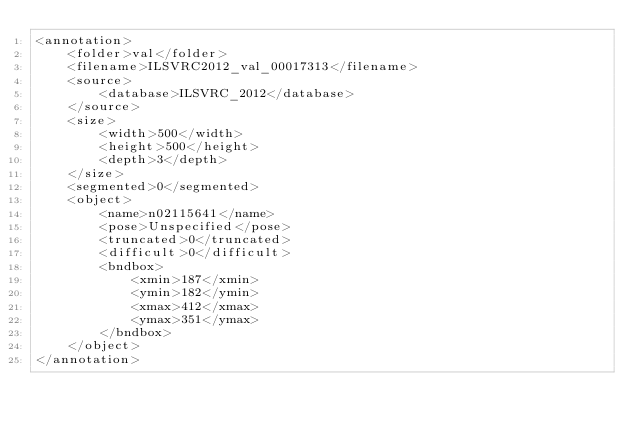Convert code to text. <code><loc_0><loc_0><loc_500><loc_500><_XML_><annotation>
	<folder>val</folder>
	<filename>ILSVRC2012_val_00017313</filename>
	<source>
		<database>ILSVRC_2012</database>
	</source>
	<size>
		<width>500</width>
		<height>500</height>
		<depth>3</depth>
	</size>
	<segmented>0</segmented>
	<object>
		<name>n02115641</name>
		<pose>Unspecified</pose>
		<truncated>0</truncated>
		<difficult>0</difficult>
		<bndbox>
			<xmin>187</xmin>
			<ymin>182</ymin>
			<xmax>412</xmax>
			<ymax>351</ymax>
		</bndbox>
	</object>
</annotation></code> 